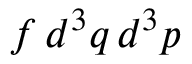<formula> <loc_0><loc_0><loc_500><loc_500>f \, d ^ { 3 } q \, d ^ { 3 } p</formula> 